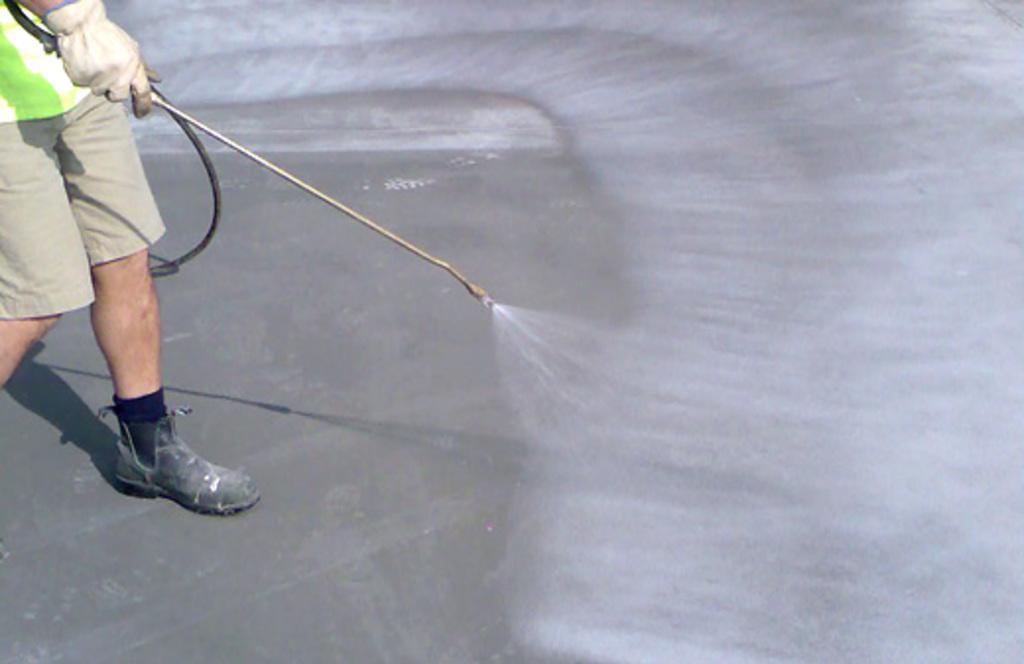Can you describe this image briefly? In the picture there is a person, he is catching and spraying. 